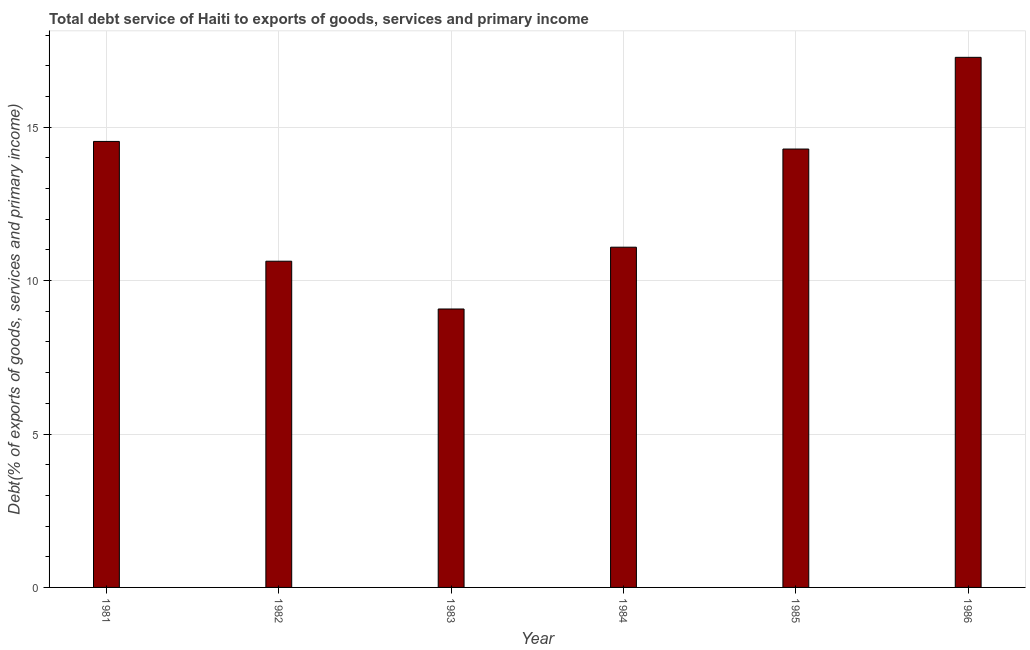Does the graph contain any zero values?
Offer a very short reply. No. Does the graph contain grids?
Your answer should be compact. Yes. What is the title of the graph?
Offer a terse response. Total debt service of Haiti to exports of goods, services and primary income. What is the label or title of the Y-axis?
Your answer should be compact. Debt(% of exports of goods, services and primary income). What is the total debt service in 1984?
Your response must be concise. 11.09. Across all years, what is the maximum total debt service?
Make the answer very short. 17.28. Across all years, what is the minimum total debt service?
Offer a very short reply. 9.08. What is the sum of the total debt service?
Keep it short and to the point. 76.9. What is the difference between the total debt service in 1981 and 1985?
Your answer should be very brief. 0.25. What is the average total debt service per year?
Provide a succinct answer. 12.82. What is the median total debt service?
Your response must be concise. 12.69. In how many years, is the total debt service greater than 6 %?
Provide a succinct answer. 6. Do a majority of the years between 1984 and 1981 (inclusive) have total debt service greater than 3 %?
Offer a terse response. Yes. What is the ratio of the total debt service in 1981 to that in 1982?
Offer a very short reply. 1.37. Is the total debt service in 1982 less than that in 1983?
Give a very brief answer. No. Is the difference between the total debt service in 1981 and 1982 greater than the difference between any two years?
Your answer should be compact. No. What is the difference between the highest and the second highest total debt service?
Offer a very short reply. 2.74. Is the sum of the total debt service in 1981 and 1983 greater than the maximum total debt service across all years?
Your response must be concise. Yes. Are all the bars in the graph horizontal?
Ensure brevity in your answer.  No. Are the values on the major ticks of Y-axis written in scientific E-notation?
Your answer should be very brief. No. What is the Debt(% of exports of goods, services and primary income) of 1981?
Your answer should be compact. 14.54. What is the Debt(% of exports of goods, services and primary income) of 1982?
Offer a terse response. 10.63. What is the Debt(% of exports of goods, services and primary income) in 1983?
Make the answer very short. 9.08. What is the Debt(% of exports of goods, services and primary income) of 1984?
Provide a succinct answer. 11.09. What is the Debt(% of exports of goods, services and primary income) of 1985?
Your answer should be compact. 14.29. What is the Debt(% of exports of goods, services and primary income) in 1986?
Your answer should be compact. 17.28. What is the difference between the Debt(% of exports of goods, services and primary income) in 1981 and 1982?
Make the answer very short. 3.9. What is the difference between the Debt(% of exports of goods, services and primary income) in 1981 and 1983?
Provide a succinct answer. 5.46. What is the difference between the Debt(% of exports of goods, services and primary income) in 1981 and 1984?
Ensure brevity in your answer.  3.45. What is the difference between the Debt(% of exports of goods, services and primary income) in 1981 and 1985?
Offer a very short reply. 0.25. What is the difference between the Debt(% of exports of goods, services and primary income) in 1981 and 1986?
Your response must be concise. -2.74. What is the difference between the Debt(% of exports of goods, services and primary income) in 1982 and 1983?
Your answer should be very brief. 1.56. What is the difference between the Debt(% of exports of goods, services and primary income) in 1982 and 1984?
Make the answer very short. -0.46. What is the difference between the Debt(% of exports of goods, services and primary income) in 1982 and 1985?
Offer a very short reply. -3.66. What is the difference between the Debt(% of exports of goods, services and primary income) in 1982 and 1986?
Your answer should be compact. -6.64. What is the difference between the Debt(% of exports of goods, services and primary income) in 1983 and 1984?
Provide a succinct answer. -2.01. What is the difference between the Debt(% of exports of goods, services and primary income) in 1983 and 1985?
Your response must be concise. -5.21. What is the difference between the Debt(% of exports of goods, services and primary income) in 1983 and 1986?
Provide a short and direct response. -8.2. What is the difference between the Debt(% of exports of goods, services and primary income) in 1984 and 1985?
Offer a very short reply. -3.2. What is the difference between the Debt(% of exports of goods, services and primary income) in 1984 and 1986?
Keep it short and to the point. -6.19. What is the difference between the Debt(% of exports of goods, services and primary income) in 1985 and 1986?
Ensure brevity in your answer.  -2.99. What is the ratio of the Debt(% of exports of goods, services and primary income) in 1981 to that in 1982?
Ensure brevity in your answer.  1.37. What is the ratio of the Debt(% of exports of goods, services and primary income) in 1981 to that in 1983?
Make the answer very short. 1.6. What is the ratio of the Debt(% of exports of goods, services and primary income) in 1981 to that in 1984?
Your answer should be compact. 1.31. What is the ratio of the Debt(% of exports of goods, services and primary income) in 1981 to that in 1985?
Your response must be concise. 1.02. What is the ratio of the Debt(% of exports of goods, services and primary income) in 1981 to that in 1986?
Ensure brevity in your answer.  0.84. What is the ratio of the Debt(% of exports of goods, services and primary income) in 1982 to that in 1983?
Offer a very short reply. 1.17. What is the ratio of the Debt(% of exports of goods, services and primary income) in 1982 to that in 1984?
Provide a short and direct response. 0.96. What is the ratio of the Debt(% of exports of goods, services and primary income) in 1982 to that in 1985?
Your answer should be very brief. 0.74. What is the ratio of the Debt(% of exports of goods, services and primary income) in 1982 to that in 1986?
Ensure brevity in your answer.  0.61. What is the ratio of the Debt(% of exports of goods, services and primary income) in 1983 to that in 1984?
Ensure brevity in your answer.  0.82. What is the ratio of the Debt(% of exports of goods, services and primary income) in 1983 to that in 1985?
Offer a terse response. 0.64. What is the ratio of the Debt(% of exports of goods, services and primary income) in 1983 to that in 1986?
Give a very brief answer. 0.53. What is the ratio of the Debt(% of exports of goods, services and primary income) in 1984 to that in 1985?
Ensure brevity in your answer.  0.78. What is the ratio of the Debt(% of exports of goods, services and primary income) in 1984 to that in 1986?
Your answer should be compact. 0.64. What is the ratio of the Debt(% of exports of goods, services and primary income) in 1985 to that in 1986?
Your response must be concise. 0.83. 